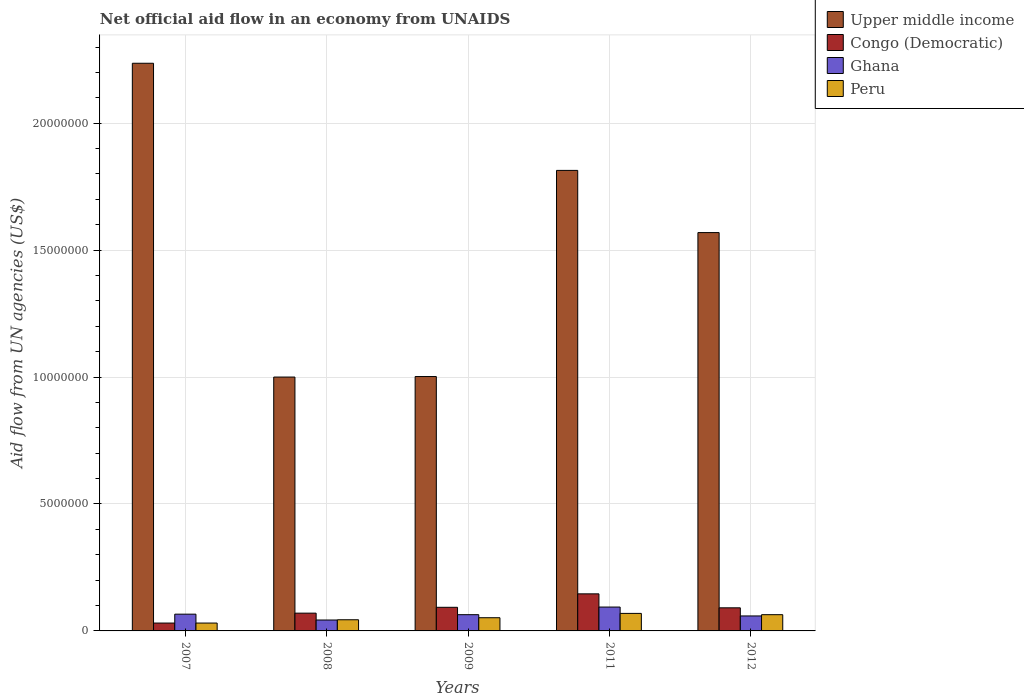How many different coloured bars are there?
Provide a succinct answer. 4. How many groups of bars are there?
Your response must be concise. 5. Are the number of bars per tick equal to the number of legend labels?
Keep it short and to the point. Yes. Are the number of bars on each tick of the X-axis equal?
Ensure brevity in your answer.  Yes. How many bars are there on the 2nd tick from the right?
Provide a succinct answer. 4. What is the net official aid flow in Ghana in 2012?
Your response must be concise. 5.90e+05. Across all years, what is the maximum net official aid flow in Ghana?
Offer a terse response. 9.40e+05. Across all years, what is the minimum net official aid flow in Ghana?
Keep it short and to the point. 4.30e+05. What is the total net official aid flow in Peru in the graph?
Your answer should be very brief. 2.60e+06. What is the difference between the net official aid flow in Congo (Democratic) in 2007 and that in 2008?
Provide a succinct answer. -3.90e+05. What is the difference between the net official aid flow in Congo (Democratic) in 2007 and the net official aid flow in Upper middle income in 2009?
Your answer should be very brief. -9.71e+06. What is the average net official aid flow in Peru per year?
Give a very brief answer. 5.20e+05. In the year 2011, what is the difference between the net official aid flow in Peru and net official aid flow in Congo (Democratic)?
Ensure brevity in your answer.  -7.70e+05. What is the ratio of the net official aid flow in Upper middle income in 2007 to that in 2011?
Your answer should be very brief. 1.23. Is the difference between the net official aid flow in Peru in 2007 and 2008 greater than the difference between the net official aid flow in Congo (Democratic) in 2007 and 2008?
Your response must be concise. Yes. What is the difference between the highest and the second highest net official aid flow in Congo (Democratic)?
Your answer should be compact. 5.30e+05. What is the difference between the highest and the lowest net official aid flow in Congo (Democratic)?
Make the answer very short. 1.15e+06. In how many years, is the net official aid flow in Congo (Democratic) greater than the average net official aid flow in Congo (Democratic) taken over all years?
Make the answer very short. 3. What does the 4th bar from the left in 2008 represents?
Your answer should be very brief. Peru. What does the 3rd bar from the right in 2012 represents?
Give a very brief answer. Congo (Democratic). Are the values on the major ticks of Y-axis written in scientific E-notation?
Keep it short and to the point. No. Does the graph contain any zero values?
Give a very brief answer. No. How are the legend labels stacked?
Your answer should be very brief. Vertical. What is the title of the graph?
Your answer should be very brief. Net official aid flow in an economy from UNAIDS. What is the label or title of the Y-axis?
Keep it short and to the point. Aid flow from UN agencies (US$). What is the Aid flow from UN agencies (US$) of Upper middle income in 2007?
Your answer should be compact. 2.24e+07. What is the Aid flow from UN agencies (US$) of Congo (Democratic) in 2007?
Your response must be concise. 3.10e+05. What is the Aid flow from UN agencies (US$) in Ghana in 2007?
Offer a terse response. 6.60e+05. What is the Aid flow from UN agencies (US$) of Upper middle income in 2009?
Provide a succinct answer. 1.00e+07. What is the Aid flow from UN agencies (US$) in Congo (Democratic) in 2009?
Make the answer very short. 9.30e+05. What is the Aid flow from UN agencies (US$) in Ghana in 2009?
Your answer should be compact. 6.40e+05. What is the Aid flow from UN agencies (US$) of Peru in 2009?
Provide a succinct answer. 5.20e+05. What is the Aid flow from UN agencies (US$) of Upper middle income in 2011?
Keep it short and to the point. 1.81e+07. What is the Aid flow from UN agencies (US$) of Congo (Democratic) in 2011?
Provide a succinct answer. 1.46e+06. What is the Aid flow from UN agencies (US$) in Ghana in 2011?
Give a very brief answer. 9.40e+05. What is the Aid flow from UN agencies (US$) of Peru in 2011?
Your response must be concise. 6.90e+05. What is the Aid flow from UN agencies (US$) in Upper middle income in 2012?
Ensure brevity in your answer.  1.57e+07. What is the Aid flow from UN agencies (US$) in Congo (Democratic) in 2012?
Provide a succinct answer. 9.10e+05. What is the Aid flow from UN agencies (US$) of Ghana in 2012?
Your answer should be very brief. 5.90e+05. What is the Aid flow from UN agencies (US$) in Peru in 2012?
Make the answer very short. 6.40e+05. Across all years, what is the maximum Aid flow from UN agencies (US$) of Upper middle income?
Your response must be concise. 2.24e+07. Across all years, what is the maximum Aid flow from UN agencies (US$) of Congo (Democratic)?
Ensure brevity in your answer.  1.46e+06. Across all years, what is the maximum Aid flow from UN agencies (US$) in Ghana?
Make the answer very short. 9.40e+05. Across all years, what is the maximum Aid flow from UN agencies (US$) in Peru?
Give a very brief answer. 6.90e+05. Across all years, what is the minimum Aid flow from UN agencies (US$) of Upper middle income?
Make the answer very short. 1.00e+07. What is the total Aid flow from UN agencies (US$) of Upper middle income in the graph?
Keep it short and to the point. 7.62e+07. What is the total Aid flow from UN agencies (US$) in Congo (Democratic) in the graph?
Keep it short and to the point. 4.31e+06. What is the total Aid flow from UN agencies (US$) of Ghana in the graph?
Provide a succinct answer. 3.26e+06. What is the total Aid flow from UN agencies (US$) in Peru in the graph?
Your response must be concise. 2.60e+06. What is the difference between the Aid flow from UN agencies (US$) of Upper middle income in 2007 and that in 2008?
Give a very brief answer. 1.24e+07. What is the difference between the Aid flow from UN agencies (US$) of Congo (Democratic) in 2007 and that in 2008?
Your response must be concise. -3.90e+05. What is the difference between the Aid flow from UN agencies (US$) in Upper middle income in 2007 and that in 2009?
Keep it short and to the point. 1.23e+07. What is the difference between the Aid flow from UN agencies (US$) in Congo (Democratic) in 2007 and that in 2009?
Offer a terse response. -6.20e+05. What is the difference between the Aid flow from UN agencies (US$) of Peru in 2007 and that in 2009?
Your response must be concise. -2.10e+05. What is the difference between the Aid flow from UN agencies (US$) of Upper middle income in 2007 and that in 2011?
Your answer should be very brief. 4.22e+06. What is the difference between the Aid flow from UN agencies (US$) in Congo (Democratic) in 2007 and that in 2011?
Give a very brief answer. -1.15e+06. What is the difference between the Aid flow from UN agencies (US$) of Ghana in 2007 and that in 2011?
Offer a very short reply. -2.80e+05. What is the difference between the Aid flow from UN agencies (US$) of Peru in 2007 and that in 2011?
Your answer should be very brief. -3.80e+05. What is the difference between the Aid flow from UN agencies (US$) in Upper middle income in 2007 and that in 2012?
Keep it short and to the point. 6.67e+06. What is the difference between the Aid flow from UN agencies (US$) of Congo (Democratic) in 2007 and that in 2012?
Your response must be concise. -6.00e+05. What is the difference between the Aid flow from UN agencies (US$) of Ghana in 2007 and that in 2012?
Keep it short and to the point. 7.00e+04. What is the difference between the Aid flow from UN agencies (US$) of Peru in 2007 and that in 2012?
Ensure brevity in your answer.  -3.30e+05. What is the difference between the Aid flow from UN agencies (US$) in Ghana in 2008 and that in 2009?
Your response must be concise. -2.10e+05. What is the difference between the Aid flow from UN agencies (US$) of Peru in 2008 and that in 2009?
Your answer should be very brief. -8.00e+04. What is the difference between the Aid flow from UN agencies (US$) of Upper middle income in 2008 and that in 2011?
Your answer should be very brief. -8.14e+06. What is the difference between the Aid flow from UN agencies (US$) in Congo (Democratic) in 2008 and that in 2011?
Keep it short and to the point. -7.60e+05. What is the difference between the Aid flow from UN agencies (US$) of Ghana in 2008 and that in 2011?
Ensure brevity in your answer.  -5.10e+05. What is the difference between the Aid flow from UN agencies (US$) of Upper middle income in 2008 and that in 2012?
Your answer should be compact. -5.69e+06. What is the difference between the Aid flow from UN agencies (US$) of Ghana in 2008 and that in 2012?
Provide a succinct answer. -1.60e+05. What is the difference between the Aid flow from UN agencies (US$) in Upper middle income in 2009 and that in 2011?
Your answer should be very brief. -8.12e+06. What is the difference between the Aid flow from UN agencies (US$) of Congo (Democratic) in 2009 and that in 2011?
Your answer should be very brief. -5.30e+05. What is the difference between the Aid flow from UN agencies (US$) of Ghana in 2009 and that in 2011?
Keep it short and to the point. -3.00e+05. What is the difference between the Aid flow from UN agencies (US$) of Upper middle income in 2009 and that in 2012?
Your answer should be compact. -5.67e+06. What is the difference between the Aid flow from UN agencies (US$) of Congo (Democratic) in 2009 and that in 2012?
Your answer should be compact. 2.00e+04. What is the difference between the Aid flow from UN agencies (US$) in Ghana in 2009 and that in 2012?
Keep it short and to the point. 5.00e+04. What is the difference between the Aid flow from UN agencies (US$) in Peru in 2009 and that in 2012?
Your answer should be compact. -1.20e+05. What is the difference between the Aid flow from UN agencies (US$) of Upper middle income in 2011 and that in 2012?
Offer a very short reply. 2.45e+06. What is the difference between the Aid flow from UN agencies (US$) in Upper middle income in 2007 and the Aid flow from UN agencies (US$) in Congo (Democratic) in 2008?
Ensure brevity in your answer.  2.17e+07. What is the difference between the Aid flow from UN agencies (US$) in Upper middle income in 2007 and the Aid flow from UN agencies (US$) in Ghana in 2008?
Keep it short and to the point. 2.19e+07. What is the difference between the Aid flow from UN agencies (US$) of Upper middle income in 2007 and the Aid flow from UN agencies (US$) of Peru in 2008?
Offer a very short reply. 2.19e+07. What is the difference between the Aid flow from UN agencies (US$) in Congo (Democratic) in 2007 and the Aid flow from UN agencies (US$) in Ghana in 2008?
Provide a short and direct response. -1.20e+05. What is the difference between the Aid flow from UN agencies (US$) of Upper middle income in 2007 and the Aid flow from UN agencies (US$) of Congo (Democratic) in 2009?
Ensure brevity in your answer.  2.14e+07. What is the difference between the Aid flow from UN agencies (US$) of Upper middle income in 2007 and the Aid flow from UN agencies (US$) of Ghana in 2009?
Provide a short and direct response. 2.17e+07. What is the difference between the Aid flow from UN agencies (US$) in Upper middle income in 2007 and the Aid flow from UN agencies (US$) in Peru in 2009?
Make the answer very short. 2.18e+07. What is the difference between the Aid flow from UN agencies (US$) of Congo (Democratic) in 2007 and the Aid flow from UN agencies (US$) of Ghana in 2009?
Make the answer very short. -3.30e+05. What is the difference between the Aid flow from UN agencies (US$) in Upper middle income in 2007 and the Aid flow from UN agencies (US$) in Congo (Democratic) in 2011?
Provide a short and direct response. 2.09e+07. What is the difference between the Aid flow from UN agencies (US$) in Upper middle income in 2007 and the Aid flow from UN agencies (US$) in Ghana in 2011?
Keep it short and to the point. 2.14e+07. What is the difference between the Aid flow from UN agencies (US$) in Upper middle income in 2007 and the Aid flow from UN agencies (US$) in Peru in 2011?
Make the answer very short. 2.17e+07. What is the difference between the Aid flow from UN agencies (US$) of Congo (Democratic) in 2007 and the Aid flow from UN agencies (US$) of Ghana in 2011?
Your answer should be compact. -6.30e+05. What is the difference between the Aid flow from UN agencies (US$) of Congo (Democratic) in 2007 and the Aid flow from UN agencies (US$) of Peru in 2011?
Your response must be concise. -3.80e+05. What is the difference between the Aid flow from UN agencies (US$) in Ghana in 2007 and the Aid flow from UN agencies (US$) in Peru in 2011?
Make the answer very short. -3.00e+04. What is the difference between the Aid flow from UN agencies (US$) in Upper middle income in 2007 and the Aid flow from UN agencies (US$) in Congo (Democratic) in 2012?
Keep it short and to the point. 2.14e+07. What is the difference between the Aid flow from UN agencies (US$) in Upper middle income in 2007 and the Aid flow from UN agencies (US$) in Ghana in 2012?
Give a very brief answer. 2.18e+07. What is the difference between the Aid flow from UN agencies (US$) in Upper middle income in 2007 and the Aid flow from UN agencies (US$) in Peru in 2012?
Offer a very short reply. 2.17e+07. What is the difference between the Aid flow from UN agencies (US$) in Congo (Democratic) in 2007 and the Aid flow from UN agencies (US$) in Ghana in 2012?
Your response must be concise. -2.80e+05. What is the difference between the Aid flow from UN agencies (US$) in Congo (Democratic) in 2007 and the Aid flow from UN agencies (US$) in Peru in 2012?
Provide a succinct answer. -3.30e+05. What is the difference between the Aid flow from UN agencies (US$) of Upper middle income in 2008 and the Aid flow from UN agencies (US$) of Congo (Democratic) in 2009?
Provide a succinct answer. 9.07e+06. What is the difference between the Aid flow from UN agencies (US$) of Upper middle income in 2008 and the Aid flow from UN agencies (US$) of Ghana in 2009?
Make the answer very short. 9.36e+06. What is the difference between the Aid flow from UN agencies (US$) of Upper middle income in 2008 and the Aid flow from UN agencies (US$) of Peru in 2009?
Your answer should be compact. 9.48e+06. What is the difference between the Aid flow from UN agencies (US$) of Congo (Democratic) in 2008 and the Aid flow from UN agencies (US$) of Ghana in 2009?
Give a very brief answer. 6.00e+04. What is the difference between the Aid flow from UN agencies (US$) in Congo (Democratic) in 2008 and the Aid flow from UN agencies (US$) in Peru in 2009?
Provide a succinct answer. 1.80e+05. What is the difference between the Aid flow from UN agencies (US$) of Ghana in 2008 and the Aid flow from UN agencies (US$) of Peru in 2009?
Your answer should be compact. -9.00e+04. What is the difference between the Aid flow from UN agencies (US$) of Upper middle income in 2008 and the Aid flow from UN agencies (US$) of Congo (Democratic) in 2011?
Provide a succinct answer. 8.54e+06. What is the difference between the Aid flow from UN agencies (US$) of Upper middle income in 2008 and the Aid flow from UN agencies (US$) of Ghana in 2011?
Ensure brevity in your answer.  9.06e+06. What is the difference between the Aid flow from UN agencies (US$) of Upper middle income in 2008 and the Aid flow from UN agencies (US$) of Peru in 2011?
Provide a short and direct response. 9.31e+06. What is the difference between the Aid flow from UN agencies (US$) in Congo (Democratic) in 2008 and the Aid flow from UN agencies (US$) in Ghana in 2011?
Give a very brief answer. -2.40e+05. What is the difference between the Aid flow from UN agencies (US$) of Upper middle income in 2008 and the Aid flow from UN agencies (US$) of Congo (Democratic) in 2012?
Your answer should be compact. 9.09e+06. What is the difference between the Aid flow from UN agencies (US$) of Upper middle income in 2008 and the Aid flow from UN agencies (US$) of Ghana in 2012?
Make the answer very short. 9.41e+06. What is the difference between the Aid flow from UN agencies (US$) of Upper middle income in 2008 and the Aid flow from UN agencies (US$) of Peru in 2012?
Keep it short and to the point. 9.36e+06. What is the difference between the Aid flow from UN agencies (US$) of Congo (Democratic) in 2008 and the Aid flow from UN agencies (US$) of Peru in 2012?
Offer a terse response. 6.00e+04. What is the difference between the Aid flow from UN agencies (US$) of Upper middle income in 2009 and the Aid flow from UN agencies (US$) of Congo (Democratic) in 2011?
Give a very brief answer. 8.56e+06. What is the difference between the Aid flow from UN agencies (US$) of Upper middle income in 2009 and the Aid flow from UN agencies (US$) of Ghana in 2011?
Ensure brevity in your answer.  9.08e+06. What is the difference between the Aid flow from UN agencies (US$) in Upper middle income in 2009 and the Aid flow from UN agencies (US$) in Peru in 2011?
Ensure brevity in your answer.  9.33e+06. What is the difference between the Aid flow from UN agencies (US$) in Ghana in 2009 and the Aid flow from UN agencies (US$) in Peru in 2011?
Keep it short and to the point. -5.00e+04. What is the difference between the Aid flow from UN agencies (US$) of Upper middle income in 2009 and the Aid flow from UN agencies (US$) of Congo (Democratic) in 2012?
Keep it short and to the point. 9.11e+06. What is the difference between the Aid flow from UN agencies (US$) of Upper middle income in 2009 and the Aid flow from UN agencies (US$) of Ghana in 2012?
Offer a terse response. 9.43e+06. What is the difference between the Aid flow from UN agencies (US$) of Upper middle income in 2009 and the Aid flow from UN agencies (US$) of Peru in 2012?
Provide a short and direct response. 9.38e+06. What is the difference between the Aid flow from UN agencies (US$) of Congo (Democratic) in 2009 and the Aid flow from UN agencies (US$) of Peru in 2012?
Offer a terse response. 2.90e+05. What is the difference between the Aid flow from UN agencies (US$) of Ghana in 2009 and the Aid flow from UN agencies (US$) of Peru in 2012?
Your answer should be very brief. 0. What is the difference between the Aid flow from UN agencies (US$) of Upper middle income in 2011 and the Aid flow from UN agencies (US$) of Congo (Democratic) in 2012?
Ensure brevity in your answer.  1.72e+07. What is the difference between the Aid flow from UN agencies (US$) in Upper middle income in 2011 and the Aid flow from UN agencies (US$) in Ghana in 2012?
Your response must be concise. 1.76e+07. What is the difference between the Aid flow from UN agencies (US$) in Upper middle income in 2011 and the Aid flow from UN agencies (US$) in Peru in 2012?
Keep it short and to the point. 1.75e+07. What is the difference between the Aid flow from UN agencies (US$) of Congo (Democratic) in 2011 and the Aid flow from UN agencies (US$) of Ghana in 2012?
Offer a very short reply. 8.70e+05. What is the difference between the Aid flow from UN agencies (US$) in Congo (Democratic) in 2011 and the Aid flow from UN agencies (US$) in Peru in 2012?
Ensure brevity in your answer.  8.20e+05. What is the average Aid flow from UN agencies (US$) in Upper middle income per year?
Offer a terse response. 1.52e+07. What is the average Aid flow from UN agencies (US$) of Congo (Democratic) per year?
Make the answer very short. 8.62e+05. What is the average Aid flow from UN agencies (US$) of Ghana per year?
Provide a succinct answer. 6.52e+05. What is the average Aid flow from UN agencies (US$) in Peru per year?
Give a very brief answer. 5.20e+05. In the year 2007, what is the difference between the Aid flow from UN agencies (US$) in Upper middle income and Aid flow from UN agencies (US$) in Congo (Democratic)?
Offer a very short reply. 2.20e+07. In the year 2007, what is the difference between the Aid flow from UN agencies (US$) of Upper middle income and Aid flow from UN agencies (US$) of Ghana?
Keep it short and to the point. 2.17e+07. In the year 2007, what is the difference between the Aid flow from UN agencies (US$) of Upper middle income and Aid flow from UN agencies (US$) of Peru?
Ensure brevity in your answer.  2.20e+07. In the year 2007, what is the difference between the Aid flow from UN agencies (US$) in Congo (Democratic) and Aid flow from UN agencies (US$) in Ghana?
Give a very brief answer. -3.50e+05. In the year 2007, what is the difference between the Aid flow from UN agencies (US$) of Congo (Democratic) and Aid flow from UN agencies (US$) of Peru?
Ensure brevity in your answer.  0. In the year 2008, what is the difference between the Aid flow from UN agencies (US$) in Upper middle income and Aid flow from UN agencies (US$) in Congo (Democratic)?
Give a very brief answer. 9.30e+06. In the year 2008, what is the difference between the Aid flow from UN agencies (US$) of Upper middle income and Aid flow from UN agencies (US$) of Ghana?
Ensure brevity in your answer.  9.57e+06. In the year 2008, what is the difference between the Aid flow from UN agencies (US$) in Upper middle income and Aid flow from UN agencies (US$) in Peru?
Make the answer very short. 9.56e+06. In the year 2008, what is the difference between the Aid flow from UN agencies (US$) of Congo (Democratic) and Aid flow from UN agencies (US$) of Ghana?
Offer a very short reply. 2.70e+05. In the year 2008, what is the difference between the Aid flow from UN agencies (US$) in Congo (Democratic) and Aid flow from UN agencies (US$) in Peru?
Your answer should be very brief. 2.60e+05. In the year 2008, what is the difference between the Aid flow from UN agencies (US$) in Ghana and Aid flow from UN agencies (US$) in Peru?
Ensure brevity in your answer.  -10000. In the year 2009, what is the difference between the Aid flow from UN agencies (US$) in Upper middle income and Aid flow from UN agencies (US$) in Congo (Democratic)?
Keep it short and to the point. 9.09e+06. In the year 2009, what is the difference between the Aid flow from UN agencies (US$) in Upper middle income and Aid flow from UN agencies (US$) in Ghana?
Offer a terse response. 9.38e+06. In the year 2009, what is the difference between the Aid flow from UN agencies (US$) in Upper middle income and Aid flow from UN agencies (US$) in Peru?
Offer a very short reply. 9.50e+06. In the year 2009, what is the difference between the Aid flow from UN agencies (US$) of Congo (Democratic) and Aid flow from UN agencies (US$) of Peru?
Your answer should be compact. 4.10e+05. In the year 2009, what is the difference between the Aid flow from UN agencies (US$) of Ghana and Aid flow from UN agencies (US$) of Peru?
Make the answer very short. 1.20e+05. In the year 2011, what is the difference between the Aid flow from UN agencies (US$) of Upper middle income and Aid flow from UN agencies (US$) of Congo (Democratic)?
Your response must be concise. 1.67e+07. In the year 2011, what is the difference between the Aid flow from UN agencies (US$) of Upper middle income and Aid flow from UN agencies (US$) of Ghana?
Keep it short and to the point. 1.72e+07. In the year 2011, what is the difference between the Aid flow from UN agencies (US$) in Upper middle income and Aid flow from UN agencies (US$) in Peru?
Your answer should be very brief. 1.74e+07. In the year 2011, what is the difference between the Aid flow from UN agencies (US$) in Congo (Democratic) and Aid flow from UN agencies (US$) in Ghana?
Keep it short and to the point. 5.20e+05. In the year 2011, what is the difference between the Aid flow from UN agencies (US$) in Congo (Democratic) and Aid flow from UN agencies (US$) in Peru?
Your response must be concise. 7.70e+05. In the year 2012, what is the difference between the Aid flow from UN agencies (US$) of Upper middle income and Aid flow from UN agencies (US$) of Congo (Democratic)?
Offer a very short reply. 1.48e+07. In the year 2012, what is the difference between the Aid flow from UN agencies (US$) of Upper middle income and Aid flow from UN agencies (US$) of Ghana?
Your answer should be compact. 1.51e+07. In the year 2012, what is the difference between the Aid flow from UN agencies (US$) of Upper middle income and Aid flow from UN agencies (US$) of Peru?
Make the answer very short. 1.50e+07. In the year 2012, what is the difference between the Aid flow from UN agencies (US$) of Congo (Democratic) and Aid flow from UN agencies (US$) of Ghana?
Provide a succinct answer. 3.20e+05. In the year 2012, what is the difference between the Aid flow from UN agencies (US$) in Congo (Democratic) and Aid flow from UN agencies (US$) in Peru?
Give a very brief answer. 2.70e+05. In the year 2012, what is the difference between the Aid flow from UN agencies (US$) of Ghana and Aid flow from UN agencies (US$) of Peru?
Your answer should be compact. -5.00e+04. What is the ratio of the Aid flow from UN agencies (US$) of Upper middle income in 2007 to that in 2008?
Give a very brief answer. 2.24. What is the ratio of the Aid flow from UN agencies (US$) of Congo (Democratic) in 2007 to that in 2008?
Offer a terse response. 0.44. What is the ratio of the Aid flow from UN agencies (US$) of Ghana in 2007 to that in 2008?
Make the answer very short. 1.53. What is the ratio of the Aid flow from UN agencies (US$) of Peru in 2007 to that in 2008?
Make the answer very short. 0.7. What is the ratio of the Aid flow from UN agencies (US$) in Upper middle income in 2007 to that in 2009?
Ensure brevity in your answer.  2.23. What is the ratio of the Aid flow from UN agencies (US$) of Ghana in 2007 to that in 2009?
Give a very brief answer. 1.03. What is the ratio of the Aid flow from UN agencies (US$) in Peru in 2007 to that in 2009?
Offer a very short reply. 0.6. What is the ratio of the Aid flow from UN agencies (US$) of Upper middle income in 2007 to that in 2011?
Your response must be concise. 1.23. What is the ratio of the Aid flow from UN agencies (US$) of Congo (Democratic) in 2007 to that in 2011?
Provide a short and direct response. 0.21. What is the ratio of the Aid flow from UN agencies (US$) of Ghana in 2007 to that in 2011?
Your answer should be compact. 0.7. What is the ratio of the Aid flow from UN agencies (US$) of Peru in 2007 to that in 2011?
Make the answer very short. 0.45. What is the ratio of the Aid flow from UN agencies (US$) in Upper middle income in 2007 to that in 2012?
Your response must be concise. 1.43. What is the ratio of the Aid flow from UN agencies (US$) in Congo (Democratic) in 2007 to that in 2012?
Ensure brevity in your answer.  0.34. What is the ratio of the Aid flow from UN agencies (US$) in Ghana in 2007 to that in 2012?
Offer a terse response. 1.12. What is the ratio of the Aid flow from UN agencies (US$) of Peru in 2007 to that in 2012?
Offer a terse response. 0.48. What is the ratio of the Aid flow from UN agencies (US$) of Congo (Democratic) in 2008 to that in 2009?
Offer a terse response. 0.75. What is the ratio of the Aid flow from UN agencies (US$) in Ghana in 2008 to that in 2009?
Your response must be concise. 0.67. What is the ratio of the Aid flow from UN agencies (US$) of Peru in 2008 to that in 2009?
Give a very brief answer. 0.85. What is the ratio of the Aid flow from UN agencies (US$) in Upper middle income in 2008 to that in 2011?
Keep it short and to the point. 0.55. What is the ratio of the Aid flow from UN agencies (US$) in Congo (Democratic) in 2008 to that in 2011?
Provide a short and direct response. 0.48. What is the ratio of the Aid flow from UN agencies (US$) of Ghana in 2008 to that in 2011?
Provide a succinct answer. 0.46. What is the ratio of the Aid flow from UN agencies (US$) in Peru in 2008 to that in 2011?
Provide a succinct answer. 0.64. What is the ratio of the Aid flow from UN agencies (US$) of Upper middle income in 2008 to that in 2012?
Offer a very short reply. 0.64. What is the ratio of the Aid flow from UN agencies (US$) in Congo (Democratic) in 2008 to that in 2012?
Offer a terse response. 0.77. What is the ratio of the Aid flow from UN agencies (US$) in Ghana in 2008 to that in 2012?
Give a very brief answer. 0.73. What is the ratio of the Aid flow from UN agencies (US$) in Peru in 2008 to that in 2012?
Offer a terse response. 0.69. What is the ratio of the Aid flow from UN agencies (US$) of Upper middle income in 2009 to that in 2011?
Offer a very short reply. 0.55. What is the ratio of the Aid flow from UN agencies (US$) of Congo (Democratic) in 2009 to that in 2011?
Offer a very short reply. 0.64. What is the ratio of the Aid flow from UN agencies (US$) of Ghana in 2009 to that in 2011?
Your response must be concise. 0.68. What is the ratio of the Aid flow from UN agencies (US$) of Peru in 2009 to that in 2011?
Give a very brief answer. 0.75. What is the ratio of the Aid flow from UN agencies (US$) in Upper middle income in 2009 to that in 2012?
Provide a succinct answer. 0.64. What is the ratio of the Aid flow from UN agencies (US$) of Ghana in 2009 to that in 2012?
Provide a short and direct response. 1.08. What is the ratio of the Aid flow from UN agencies (US$) of Peru in 2009 to that in 2012?
Provide a succinct answer. 0.81. What is the ratio of the Aid flow from UN agencies (US$) of Upper middle income in 2011 to that in 2012?
Ensure brevity in your answer.  1.16. What is the ratio of the Aid flow from UN agencies (US$) in Congo (Democratic) in 2011 to that in 2012?
Ensure brevity in your answer.  1.6. What is the ratio of the Aid flow from UN agencies (US$) of Ghana in 2011 to that in 2012?
Your answer should be very brief. 1.59. What is the ratio of the Aid flow from UN agencies (US$) in Peru in 2011 to that in 2012?
Offer a terse response. 1.08. What is the difference between the highest and the second highest Aid flow from UN agencies (US$) of Upper middle income?
Ensure brevity in your answer.  4.22e+06. What is the difference between the highest and the second highest Aid flow from UN agencies (US$) of Congo (Democratic)?
Keep it short and to the point. 5.30e+05. What is the difference between the highest and the lowest Aid flow from UN agencies (US$) in Upper middle income?
Offer a terse response. 1.24e+07. What is the difference between the highest and the lowest Aid flow from UN agencies (US$) of Congo (Democratic)?
Make the answer very short. 1.15e+06. What is the difference between the highest and the lowest Aid flow from UN agencies (US$) of Ghana?
Give a very brief answer. 5.10e+05. 